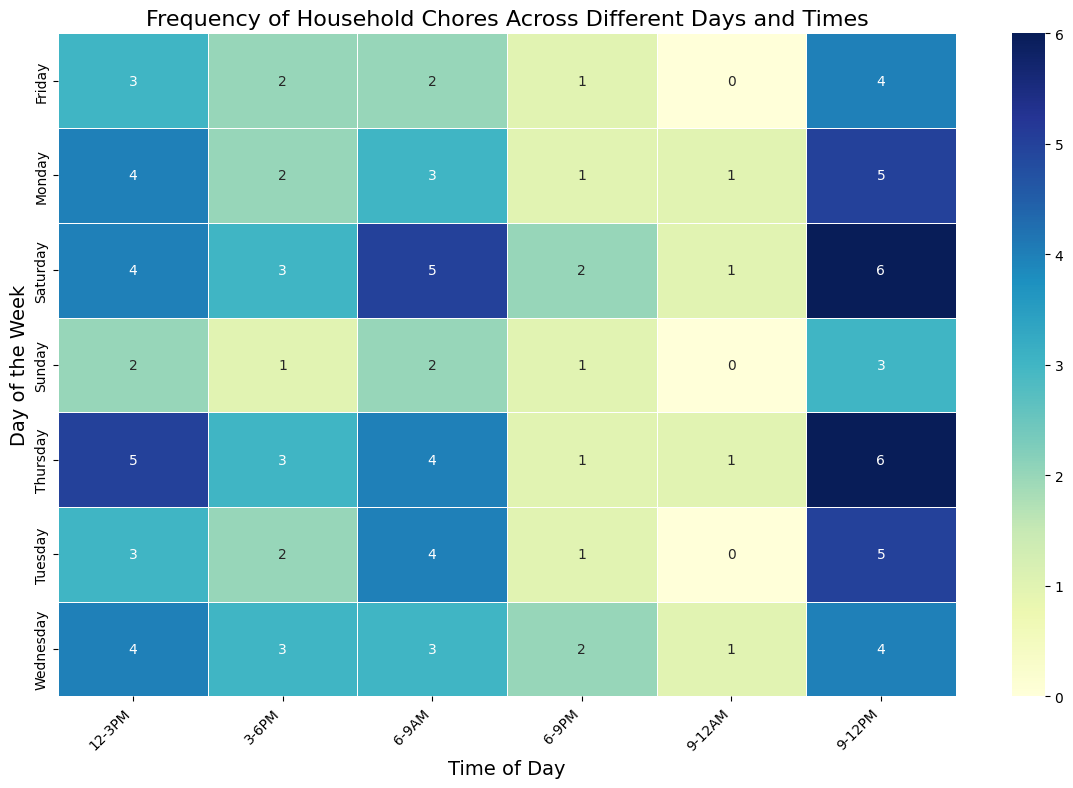What day has the highest frequency of chores between 9 AM and 12 PM? The heatmap shows numbers representing the frequency of chores. For 9 AM - 12 PM, we need to find the day with the highest number. Looking closely, Thursday and Saturday have a value of 6, which is the highest.
Answer: Thursday and Saturday Which day has the lowest frequency of chores for the 3 PM - 6 PM time slot? Look across the 3 PM - 6 PM column to find the smallest value. The lowest number is 1, which appears on Sunday.
Answer: Sunday What is the total frequency of chores on Monday? Sum the numbers in the row for Monday: 3 + 5 + 4 + 2 + 1 + 1 = 16.
Answer: 16 Compare the frequency of chores between 6 AM - 9 AM and 9 AM - 12 PM on Saturday. Which time slot has more chores, and by how much? Saturday has frequencies of 5 (6 AM - 9 AM) and 6 (9 AM - 12 PM). Subtract the smaller value from the larger one to find the difference: 6 - 5 = 1.
Answer: 9 AM - 12 PM by 1 How many times do chores happen between 12 PM - 3 PM across the entire week? Calculate the sum of the 12 PM - 3 PM column: 4 + 3 + 4 + 5 + 3 + 4 + 2 = 25.
Answer: 25 On which day are chores most evenly distributed across the different time slots? Look for a row where the values are closest to each other. Wednesday has values of 3, 4, 4, 3, 2, 1, which are fairly close.
Answer: Wednesday Is the frequency of chores higher in the morning (6 AM - 12 PM) or in the afternoon (12 PM - 6 PM) on Thursday? For morning: 4 + 6 = 10. For afternoon: 5 + 3 = 8. Compare the sums to see which is higher.
Answer: Morning Which day has the most frequency of chores during the 6 PM - 9 PM time slot? Check the 6 PM - 9 PM column to find the highest value, which is 2 on Saturday.
Answer: Saturday What is the average frequency of chores in the 9 PM - 12 AM time slot? Calculate the average by summing the values and dividing by the number of days: (1 + 0 + 1 + 1 + 0 + 1 + 0) / 7 ≈ 0.57.
Answer: 0.57 Which time slot has the highest overall frequency of chores across all days? Sum each column and compare to find the highest. The 9 AM - 12 PM slot has the highest sum of 34.
Answer: 9 AM - 12 PM 